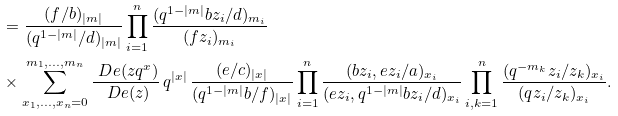<formula> <loc_0><loc_0><loc_500><loc_500>& \quad = \frac { ( f / b ) _ { | m | } } { ( q ^ { 1 - | m | } / d ) _ { | m | } } \prod _ { i = 1 } ^ { n } \frac { ( q ^ { 1 - | m | } b z _ { i } / d ) _ { m _ { i } } } { ( f z _ { i } ) _ { m _ { i } } } \\ & \quad \times \sum _ { x _ { 1 } , \dots , x _ { n } = 0 } ^ { m _ { 1 } , \dots , m _ { n } } \frac { \ D e ( z q ^ { x } ) } { \ D e ( z ) } \, q ^ { | x | } \, \frac { ( e / c ) _ { | x | } } { ( q ^ { 1 - | m | } b / f ) _ { | x | } } \prod _ { i = 1 } ^ { n } \frac { ( b z _ { i } , e z _ { i } / a ) _ { x _ { i } } } { ( e z _ { i } , q ^ { 1 - | m | } b z _ { i } / d ) _ { x _ { i } } } \prod _ { i , k = 1 } ^ { n } \frac { ( q ^ { - m _ { k } } z _ { i } / z _ { k } ) _ { x _ { i } } } { ( q z _ { i } / z _ { k } ) _ { x _ { i } } } .</formula> 